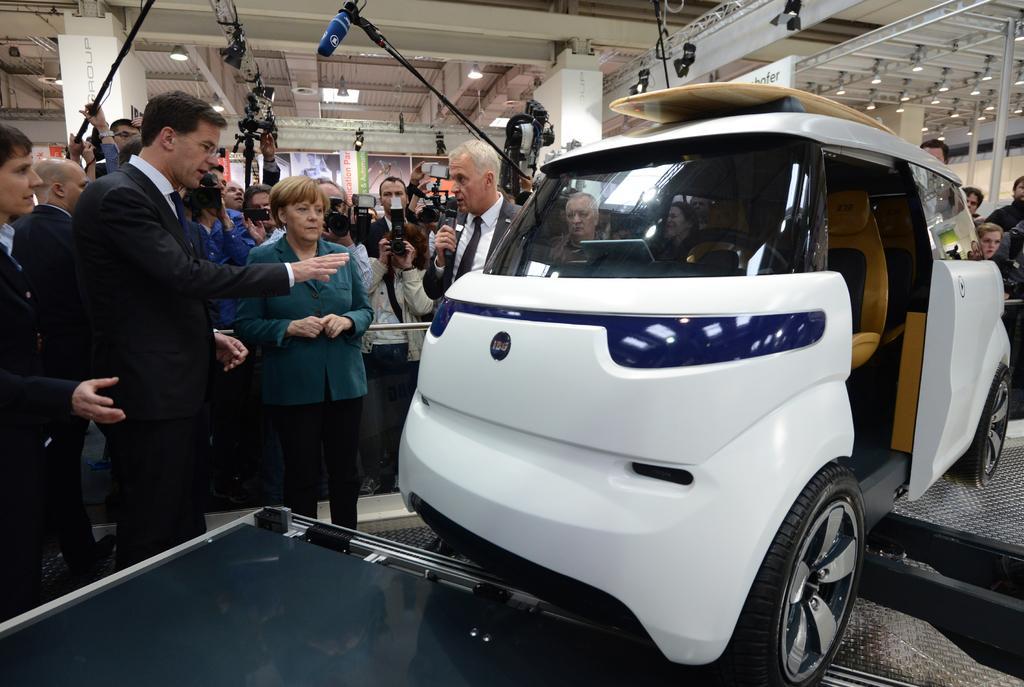Please provide a concise description of this image. In front of the image there is a car, behind the car there are a few people standing and holding cameras and mics in their hands. 